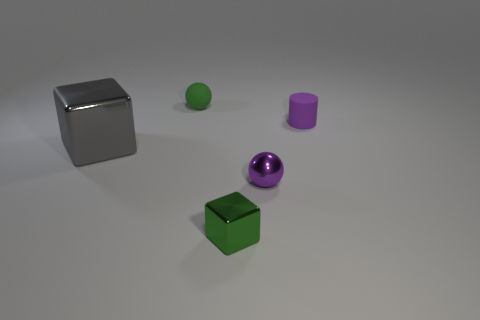Add 4 yellow cylinders. How many objects exist? 9 Subtract all blocks. How many objects are left? 3 Subtract all big balls. Subtract all green rubber objects. How many objects are left? 4 Add 4 purple matte cylinders. How many purple matte cylinders are left? 5 Add 5 green cubes. How many green cubes exist? 6 Subtract 0 red cylinders. How many objects are left? 5 